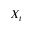Convert formula to latex. <formula><loc_0><loc_0><loc_500><loc_500>X _ { t }</formula> 